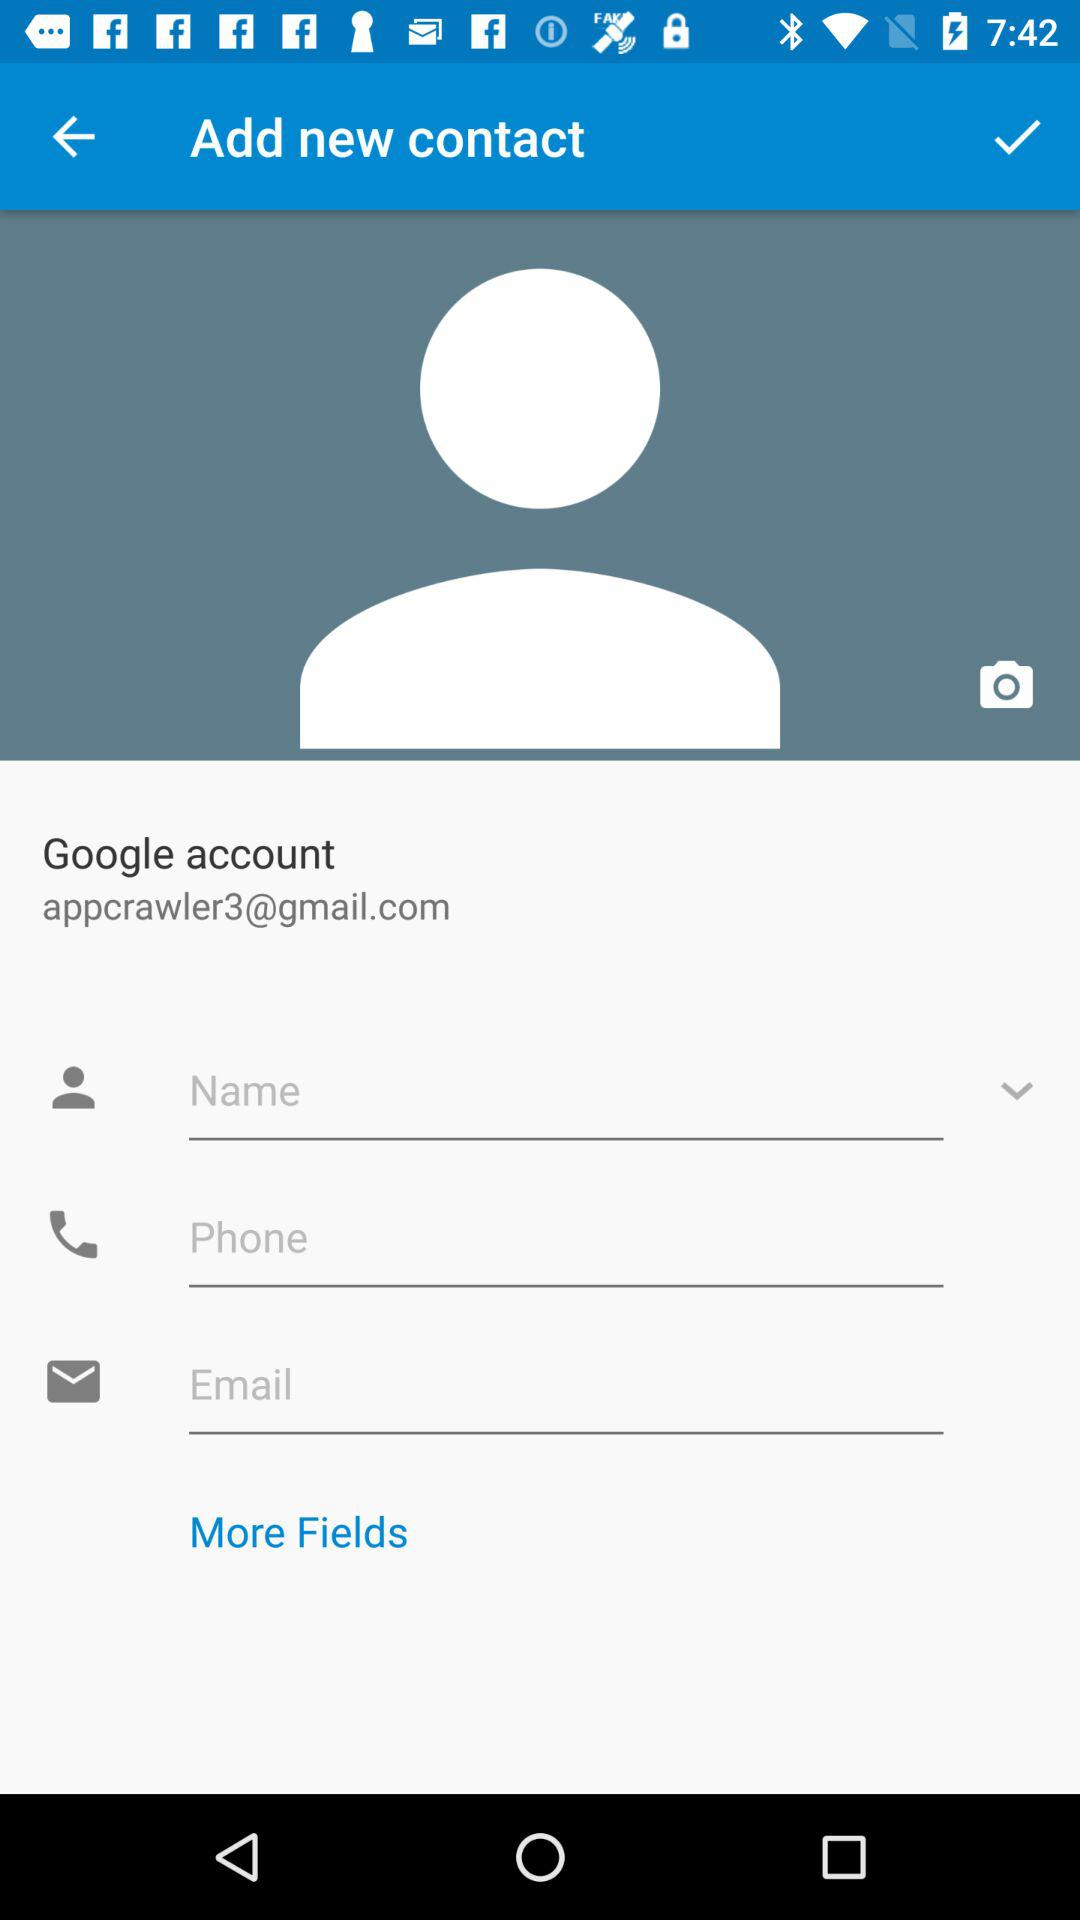How many fields are there for contact information?
Answer the question using a single word or phrase. 3 